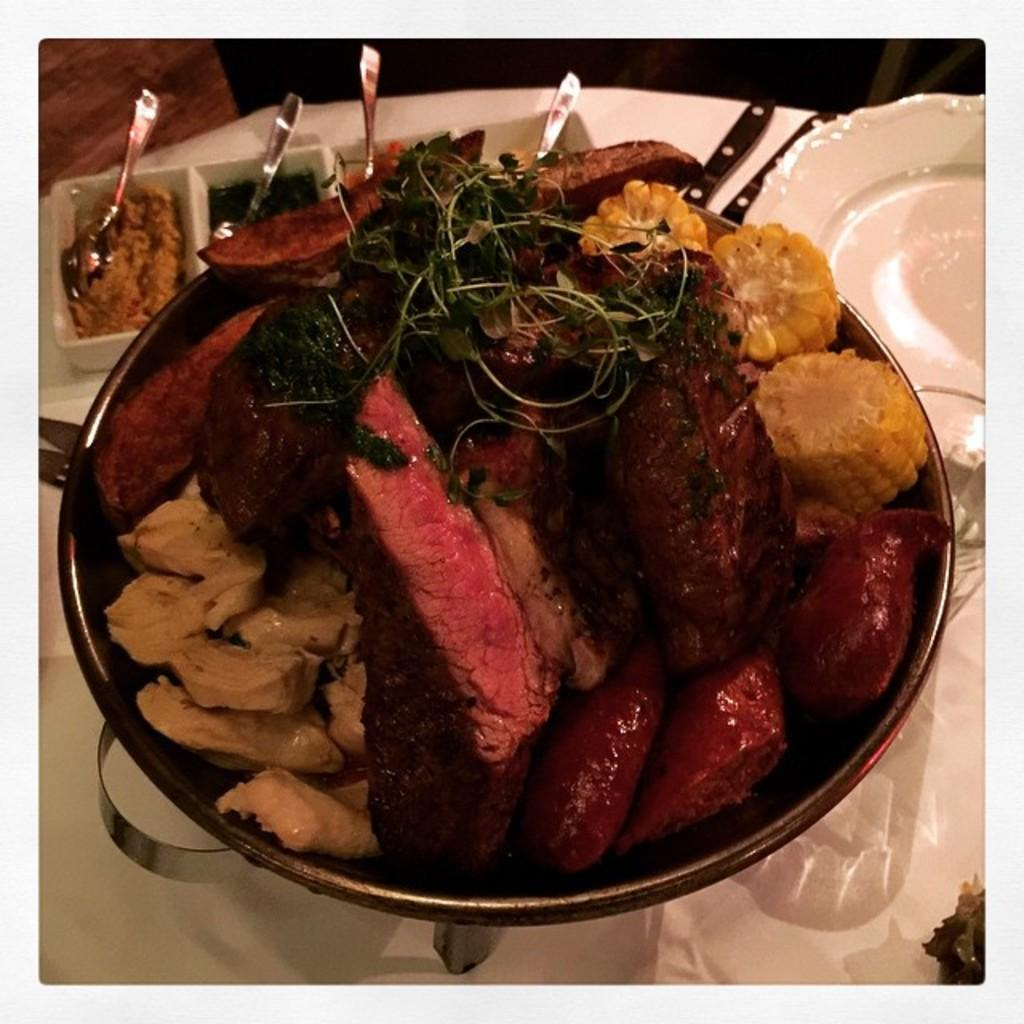What is in the bowl that is visible in the image? There is a bowl with meat items in the image. What utensils are present in the image? There are spoons in a plate in the image. What type of bike can be seen in the image? There is no bike present in the image. What liquid is being used to cook the meat items in the image? The image does not show any liquid being used to cook the meat items; it only shows the bowl with the meat items. 